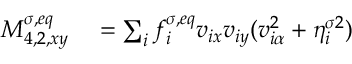Convert formula to latex. <formula><loc_0><loc_0><loc_500><loc_500>\begin{array} { r } { \begin{array} { r l } { M _ { 4 , 2 , x y } ^ { \sigma , e q } } & = \sum _ { i } f _ { i } ^ { \sigma , e q } v _ { i x } v _ { i y } ( v _ { i \alpha } ^ { 2 } + \eta _ { i } ^ { \sigma 2 } ) } \end{array} } \end{array}</formula> 